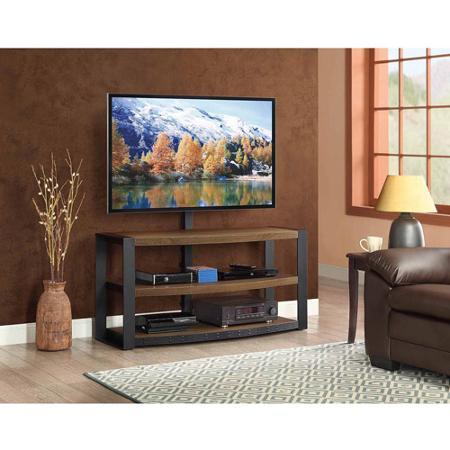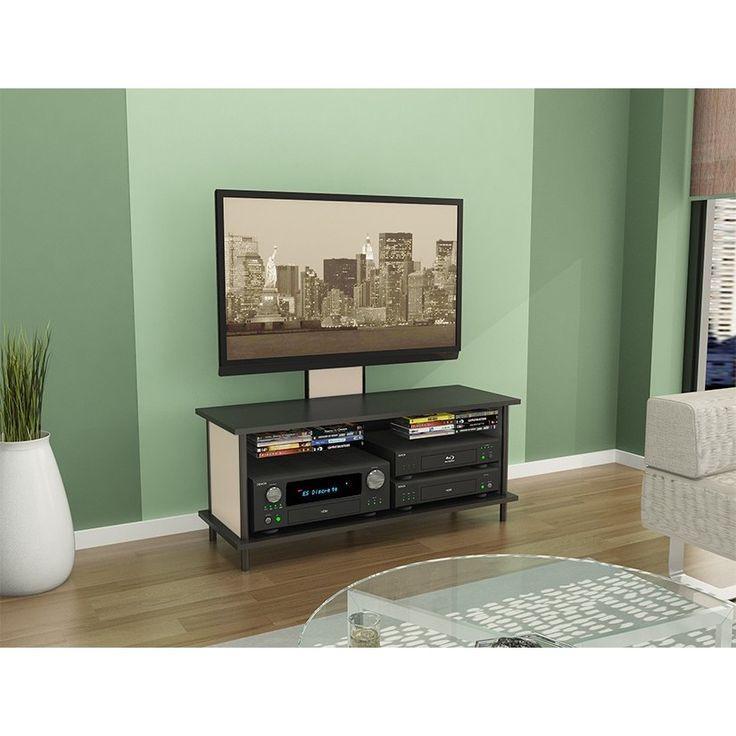The first image is the image on the left, the second image is the image on the right. For the images displayed, is the sentence "The right image features a TV stand with Z-shaped ends formed by a curved diagonal piece, and the left image features a stand with at least one X-shape per end." factually correct? Answer yes or no. No. 